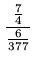<formula> <loc_0><loc_0><loc_500><loc_500>\frac { \frac { 7 } { 4 } } { \frac { 6 } { 3 7 7 } }</formula> 